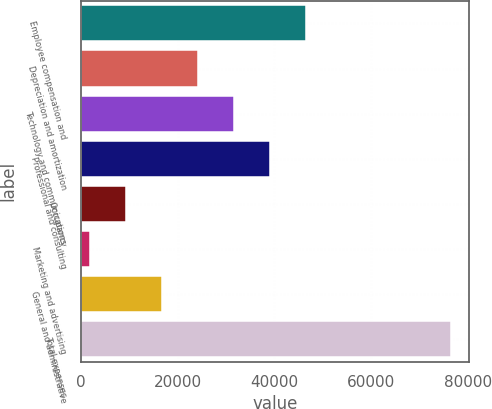Convert chart to OTSL. <chart><loc_0><loc_0><loc_500><loc_500><bar_chart><fcel>Employee compensation and<fcel>Depreciation and amortization<fcel>Technology and communications<fcel>Professional and consulting<fcel>Occupancy<fcel>Marketing and advertising<fcel>General and administrative<fcel>Total expenses<nl><fcel>46597.2<fcel>24251.1<fcel>31699.8<fcel>39148.5<fcel>9353.7<fcel>1905<fcel>16802.4<fcel>76392<nl></chart> 